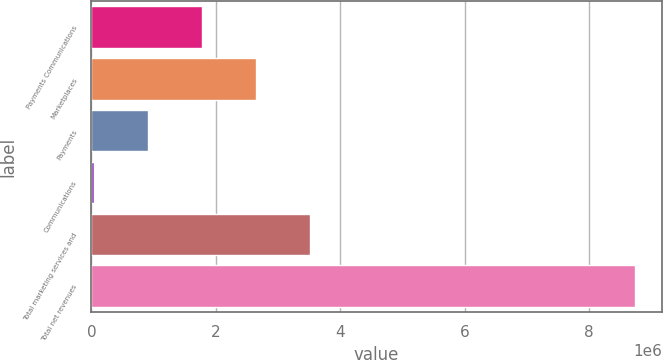Convert chart. <chart><loc_0><loc_0><loc_500><loc_500><bar_chart><fcel>Payments Communications<fcel>Marketplaces<fcel>Payments<fcel>Communications<fcel>Total marketing services and<fcel>Total net revenues<nl><fcel>1.78172e+06<fcel>2.64992e+06<fcel>913512<fcel>45307<fcel>3.51813e+06<fcel>8.72736e+06<nl></chart> 